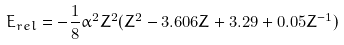Convert formula to latex. <formula><loc_0><loc_0><loc_500><loc_500>E _ { r e l } = - \frac { 1 } { 8 } \alpha ^ { 2 } Z ^ { 2 } ( Z ^ { 2 } - 3 . 6 0 6 Z + 3 . 2 9 + 0 . 0 5 Z ^ { - 1 } )</formula> 